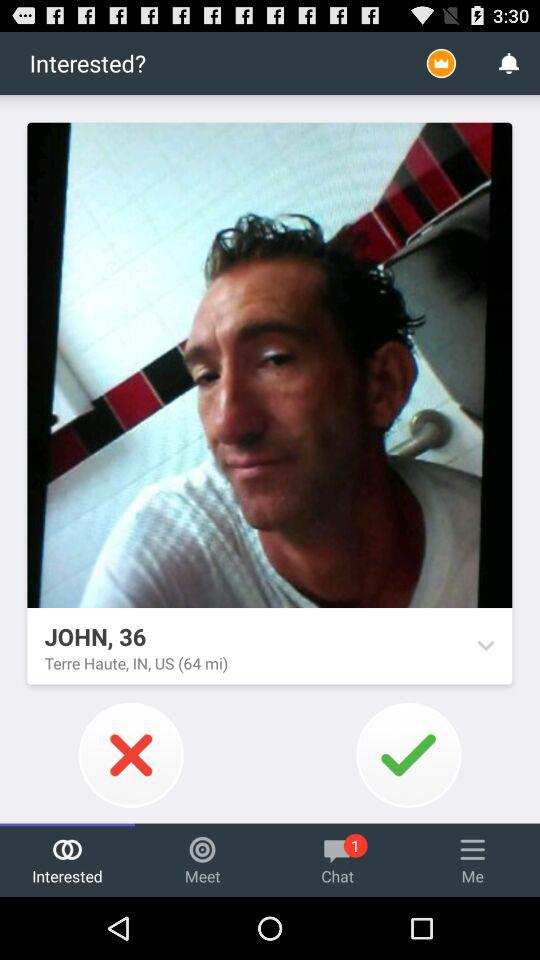What is the name? The name is John. 